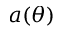Convert formula to latex. <formula><loc_0><loc_0><loc_500><loc_500>a ( \theta )</formula> 